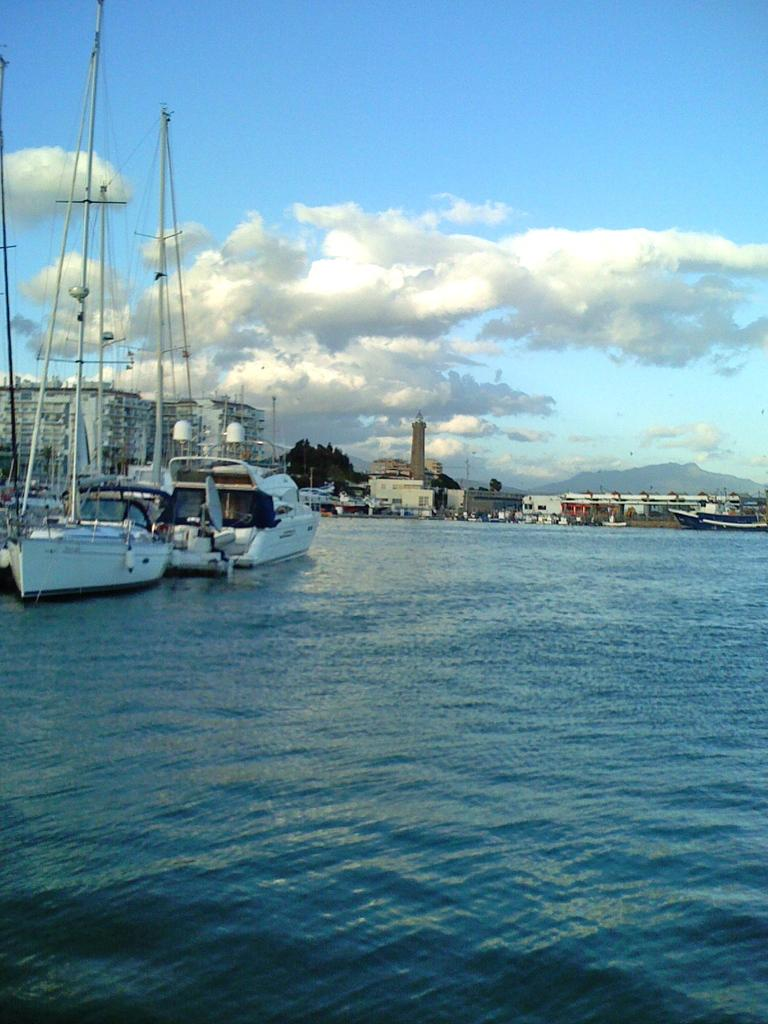What is on the water in the image? There are ships on the water in the image. What can be seen in the background of the image? There are buildings, trees, and mountains visible in the background of the image. What is visible at the top of the image? The sky is visible at the top of the image. Can you see the moon in the image? There is no moon visible in the image; only the sky, ships, buildings, trees, and mountains are present. What type of stick is being used to shade the ships in the image? There is no stick or shading device present in the image; the ships are on the water without any additional objects. 